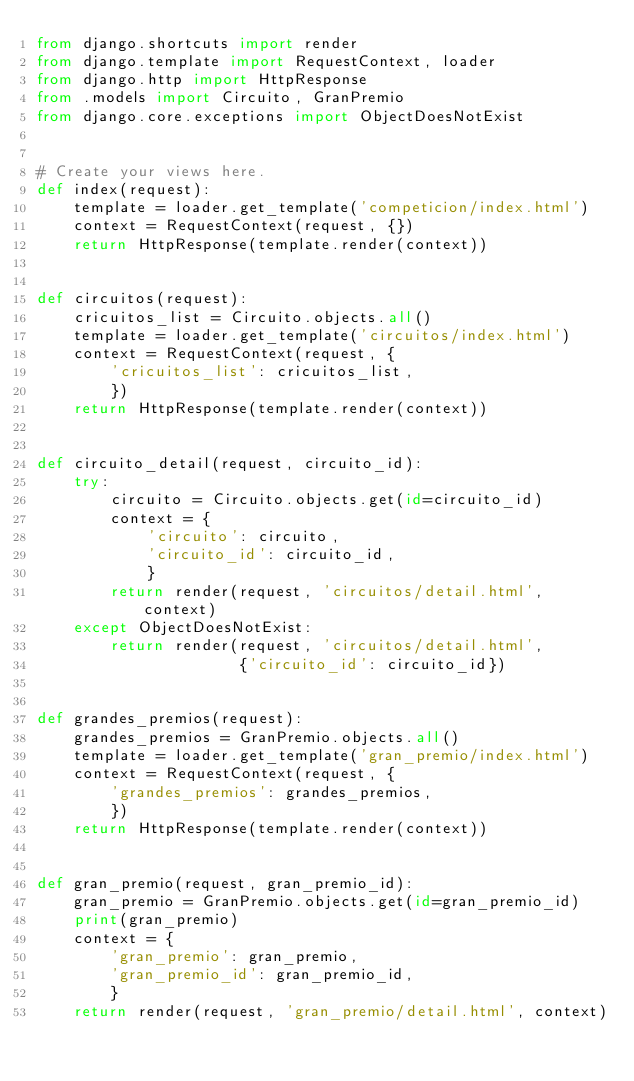Convert code to text. <code><loc_0><loc_0><loc_500><loc_500><_Python_>from django.shortcuts import render
from django.template import RequestContext, loader
from django.http import HttpResponse
from .models import Circuito, GranPremio
from django.core.exceptions import ObjectDoesNotExist


# Create your views here.
def index(request):
    template = loader.get_template('competicion/index.html')
    context = RequestContext(request, {})
    return HttpResponse(template.render(context))


def circuitos(request):
    cricuitos_list = Circuito.objects.all()
    template = loader.get_template('circuitos/index.html')
    context = RequestContext(request, {
        'cricuitos_list': cricuitos_list,
        })
    return HttpResponse(template.render(context))


def circuito_detail(request, circuito_id):
    try:
        circuito = Circuito.objects.get(id=circuito_id)
        context = {
            'circuito': circuito,
            'circuito_id': circuito_id,
            }
        return render(request, 'circuitos/detail.html', context)
    except ObjectDoesNotExist:
        return render(request, 'circuitos/detail.html',
                      {'circuito_id': circuito_id})


def grandes_premios(request):
    grandes_premios = GranPremio.objects.all()
    template = loader.get_template('gran_premio/index.html')
    context = RequestContext(request, {
        'grandes_premios': grandes_premios,
        })
    return HttpResponse(template.render(context))


def gran_premio(request, gran_premio_id):
    gran_premio = GranPremio.objects.get(id=gran_premio_id)
    print(gran_premio)
    context = {
        'gran_premio': gran_premio,
        'gran_premio_id': gran_premio_id,
        }
    return render(request, 'gran_premio/detail.html', context)
</code> 